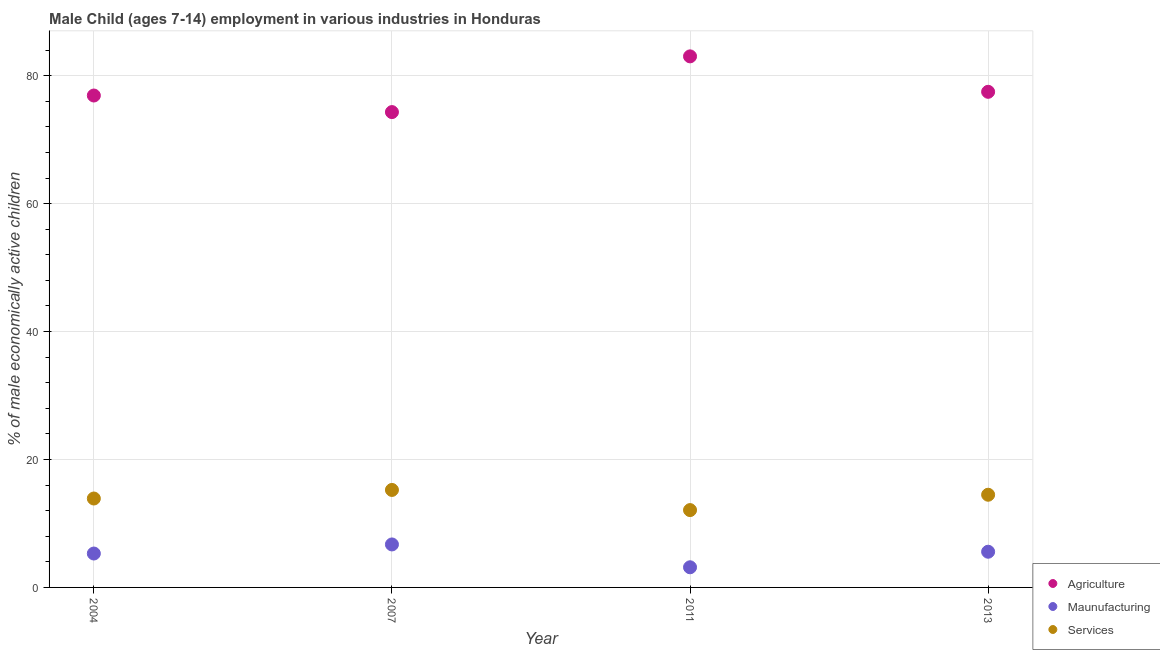What is the percentage of economically active children in agriculture in 2007?
Keep it short and to the point. 74.31. Across all years, what is the maximum percentage of economically active children in services?
Keep it short and to the point. 15.24. Across all years, what is the minimum percentage of economically active children in agriculture?
Offer a terse response. 74.31. In which year was the percentage of economically active children in manufacturing maximum?
Keep it short and to the point. 2007. What is the total percentage of economically active children in agriculture in the graph?
Provide a succinct answer. 311.71. What is the difference between the percentage of economically active children in agriculture in 2004 and that in 2007?
Provide a succinct answer. 2.59. What is the difference between the percentage of economically active children in manufacturing in 2013 and the percentage of economically active children in agriculture in 2004?
Your response must be concise. -71.32. What is the average percentage of economically active children in services per year?
Your answer should be very brief. 13.93. In the year 2004, what is the difference between the percentage of economically active children in manufacturing and percentage of economically active children in agriculture?
Provide a succinct answer. -71.6. What is the ratio of the percentage of economically active children in agriculture in 2007 to that in 2013?
Give a very brief answer. 0.96. Is the percentage of economically active children in services in 2011 less than that in 2013?
Keep it short and to the point. Yes. What is the difference between the highest and the second highest percentage of economically active children in manufacturing?
Ensure brevity in your answer.  1.14. What is the difference between the highest and the lowest percentage of economically active children in agriculture?
Provide a succinct answer. 8.71. Is it the case that in every year, the sum of the percentage of economically active children in agriculture and percentage of economically active children in manufacturing is greater than the percentage of economically active children in services?
Give a very brief answer. Yes. Is the percentage of economically active children in services strictly less than the percentage of economically active children in agriculture over the years?
Your response must be concise. Yes. How many years are there in the graph?
Your response must be concise. 4. Does the graph contain any zero values?
Provide a succinct answer. No. Where does the legend appear in the graph?
Your answer should be very brief. Bottom right. How many legend labels are there?
Provide a short and direct response. 3. What is the title of the graph?
Provide a short and direct response. Male Child (ages 7-14) employment in various industries in Honduras. What is the label or title of the Y-axis?
Give a very brief answer. % of male economically active children. What is the % of male economically active children in Agriculture in 2004?
Give a very brief answer. 76.9. What is the % of male economically active children in Services in 2004?
Provide a short and direct response. 13.9. What is the % of male economically active children in Agriculture in 2007?
Offer a very short reply. 74.31. What is the % of male economically active children in Maunufacturing in 2007?
Provide a short and direct response. 6.72. What is the % of male economically active children in Services in 2007?
Offer a terse response. 15.24. What is the % of male economically active children in Agriculture in 2011?
Make the answer very short. 83.02. What is the % of male economically active children of Maunufacturing in 2011?
Make the answer very short. 3.15. What is the % of male economically active children of Services in 2011?
Make the answer very short. 12.09. What is the % of male economically active children in Agriculture in 2013?
Your response must be concise. 77.48. What is the % of male economically active children in Maunufacturing in 2013?
Make the answer very short. 5.58. What is the % of male economically active children of Services in 2013?
Make the answer very short. 14.49. Across all years, what is the maximum % of male economically active children in Agriculture?
Provide a succinct answer. 83.02. Across all years, what is the maximum % of male economically active children of Maunufacturing?
Provide a succinct answer. 6.72. Across all years, what is the maximum % of male economically active children of Services?
Ensure brevity in your answer.  15.24. Across all years, what is the minimum % of male economically active children of Agriculture?
Your answer should be compact. 74.31. Across all years, what is the minimum % of male economically active children of Maunufacturing?
Your response must be concise. 3.15. Across all years, what is the minimum % of male economically active children in Services?
Ensure brevity in your answer.  12.09. What is the total % of male economically active children of Agriculture in the graph?
Give a very brief answer. 311.71. What is the total % of male economically active children of Maunufacturing in the graph?
Your answer should be compact. 20.75. What is the total % of male economically active children in Services in the graph?
Your response must be concise. 55.72. What is the difference between the % of male economically active children of Agriculture in 2004 and that in 2007?
Your answer should be very brief. 2.59. What is the difference between the % of male economically active children of Maunufacturing in 2004 and that in 2007?
Offer a very short reply. -1.42. What is the difference between the % of male economically active children in Services in 2004 and that in 2007?
Your answer should be very brief. -1.34. What is the difference between the % of male economically active children in Agriculture in 2004 and that in 2011?
Your response must be concise. -6.12. What is the difference between the % of male economically active children of Maunufacturing in 2004 and that in 2011?
Your answer should be very brief. 2.15. What is the difference between the % of male economically active children in Services in 2004 and that in 2011?
Offer a terse response. 1.81. What is the difference between the % of male economically active children in Agriculture in 2004 and that in 2013?
Offer a very short reply. -0.58. What is the difference between the % of male economically active children in Maunufacturing in 2004 and that in 2013?
Ensure brevity in your answer.  -0.28. What is the difference between the % of male economically active children of Services in 2004 and that in 2013?
Offer a terse response. -0.59. What is the difference between the % of male economically active children in Agriculture in 2007 and that in 2011?
Keep it short and to the point. -8.71. What is the difference between the % of male economically active children in Maunufacturing in 2007 and that in 2011?
Your answer should be very brief. 3.57. What is the difference between the % of male economically active children of Services in 2007 and that in 2011?
Your answer should be very brief. 3.15. What is the difference between the % of male economically active children in Agriculture in 2007 and that in 2013?
Provide a short and direct response. -3.17. What is the difference between the % of male economically active children of Maunufacturing in 2007 and that in 2013?
Ensure brevity in your answer.  1.14. What is the difference between the % of male economically active children of Agriculture in 2011 and that in 2013?
Provide a short and direct response. 5.54. What is the difference between the % of male economically active children of Maunufacturing in 2011 and that in 2013?
Offer a very short reply. -2.43. What is the difference between the % of male economically active children of Services in 2011 and that in 2013?
Provide a succinct answer. -2.4. What is the difference between the % of male economically active children in Agriculture in 2004 and the % of male economically active children in Maunufacturing in 2007?
Offer a very short reply. 70.18. What is the difference between the % of male economically active children in Agriculture in 2004 and the % of male economically active children in Services in 2007?
Offer a very short reply. 61.66. What is the difference between the % of male economically active children in Maunufacturing in 2004 and the % of male economically active children in Services in 2007?
Ensure brevity in your answer.  -9.94. What is the difference between the % of male economically active children of Agriculture in 2004 and the % of male economically active children of Maunufacturing in 2011?
Offer a very short reply. 73.75. What is the difference between the % of male economically active children of Agriculture in 2004 and the % of male economically active children of Services in 2011?
Make the answer very short. 64.81. What is the difference between the % of male economically active children in Maunufacturing in 2004 and the % of male economically active children in Services in 2011?
Your response must be concise. -6.79. What is the difference between the % of male economically active children of Agriculture in 2004 and the % of male economically active children of Maunufacturing in 2013?
Your answer should be compact. 71.32. What is the difference between the % of male economically active children in Agriculture in 2004 and the % of male economically active children in Services in 2013?
Provide a succinct answer. 62.41. What is the difference between the % of male economically active children in Maunufacturing in 2004 and the % of male economically active children in Services in 2013?
Offer a terse response. -9.19. What is the difference between the % of male economically active children of Agriculture in 2007 and the % of male economically active children of Maunufacturing in 2011?
Keep it short and to the point. 71.16. What is the difference between the % of male economically active children in Agriculture in 2007 and the % of male economically active children in Services in 2011?
Provide a short and direct response. 62.22. What is the difference between the % of male economically active children in Maunufacturing in 2007 and the % of male economically active children in Services in 2011?
Offer a terse response. -5.37. What is the difference between the % of male economically active children of Agriculture in 2007 and the % of male economically active children of Maunufacturing in 2013?
Make the answer very short. 68.73. What is the difference between the % of male economically active children of Agriculture in 2007 and the % of male economically active children of Services in 2013?
Your answer should be compact. 59.82. What is the difference between the % of male economically active children of Maunufacturing in 2007 and the % of male economically active children of Services in 2013?
Give a very brief answer. -7.77. What is the difference between the % of male economically active children in Agriculture in 2011 and the % of male economically active children in Maunufacturing in 2013?
Your response must be concise. 77.44. What is the difference between the % of male economically active children of Agriculture in 2011 and the % of male economically active children of Services in 2013?
Make the answer very short. 68.53. What is the difference between the % of male economically active children of Maunufacturing in 2011 and the % of male economically active children of Services in 2013?
Keep it short and to the point. -11.34. What is the average % of male economically active children in Agriculture per year?
Your response must be concise. 77.93. What is the average % of male economically active children in Maunufacturing per year?
Ensure brevity in your answer.  5.19. What is the average % of male economically active children of Services per year?
Keep it short and to the point. 13.93. In the year 2004, what is the difference between the % of male economically active children of Agriculture and % of male economically active children of Maunufacturing?
Make the answer very short. 71.6. In the year 2007, what is the difference between the % of male economically active children of Agriculture and % of male economically active children of Maunufacturing?
Your answer should be compact. 67.59. In the year 2007, what is the difference between the % of male economically active children in Agriculture and % of male economically active children in Services?
Make the answer very short. 59.07. In the year 2007, what is the difference between the % of male economically active children of Maunufacturing and % of male economically active children of Services?
Provide a succinct answer. -8.52. In the year 2011, what is the difference between the % of male economically active children of Agriculture and % of male economically active children of Maunufacturing?
Offer a terse response. 79.87. In the year 2011, what is the difference between the % of male economically active children of Agriculture and % of male economically active children of Services?
Your response must be concise. 70.93. In the year 2011, what is the difference between the % of male economically active children in Maunufacturing and % of male economically active children in Services?
Offer a very short reply. -8.94. In the year 2013, what is the difference between the % of male economically active children in Agriculture and % of male economically active children in Maunufacturing?
Provide a short and direct response. 71.9. In the year 2013, what is the difference between the % of male economically active children in Agriculture and % of male economically active children in Services?
Offer a terse response. 62.99. In the year 2013, what is the difference between the % of male economically active children of Maunufacturing and % of male economically active children of Services?
Your answer should be compact. -8.91. What is the ratio of the % of male economically active children of Agriculture in 2004 to that in 2007?
Give a very brief answer. 1.03. What is the ratio of the % of male economically active children of Maunufacturing in 2004 to that in 2007?
Offer a very short reply. 0.79. What is the ratio of the % of male economically active children in Services in 2004 to that in 2007?
Your answer should be compact. 0.91. What is the ratio of the % of male economically active children in Agriculture in 2004 to that in 2011?
Your answer should be compact. 0.93. What is the ratio of the % of male economically active children in Maunufacturing in 2004 to that in 2011?
Your response must be concise. 1.68. What is the ratio of the % of male economically active children of Services in 2004 to that in 2011?
Give a very brief answer. 1.15. What is the ratio of the % of male economically active children in Maunufacturing in 2004 to that in 2013?
Keep it short and to the point. 0.95. What is the ratio of the % of male economically active children of Services in 2004 to that in 2013?
Provide a succinct answer. 0.96. What is the ratio of the % of male economically active children of Agriculture in 2007 to that in 2011?
Provide a short and direct response. 0.9. What is the ratio of the % of male economically active children of Maunufacturing in 2007 to that in 2011?
Offer a terse response. 2.13. What is the ratio of the % of male economically active children in Services in 2007 to that in 2011?
Offer a terse response. 1.26. What is the ratio of the % of male economically active children in Agriculture in 2007 to that in 2013?
Give a very brief answer. 0.96. What is the ratio of the % of male economically active children of Maunufacturing in 2007 to that in 2013?
Keep it short and to the point. 1.2. What is the ratio of the % of male economically active children of Services in 2007 to that in 2013?
Offer a terse response. 1.05. What is the ratio of the % of male economically active children in Agriculture in 2011 to that in 2013?
Your answer should be compact. 1.07. What is the ratio of the % of male economically active children in Maunufacturing in 2011 to that in 2013?
Make the answer very short. 0.56. What is the ratio of the % of male economically active children in Services in 2011 to that in 2013?
Give a very brief answer. 0.83. What is the difference between the highest and the second highest % of male economically active children in Agriculture?
Your answer should be very brief. 5.54. What is the difference between the highest and the second highest % of male economically active children of Maunufacturing?
Keep it short and to the point. 1.14. What is the difference between the highest and the second highest % of male economically active children of Services?
Your answer should be compact. 0.75. What is the difference between the highest and the lowest % of male economically active children in Agriculture?
Offer a terse response. 8.71. What is the difference between the highest and the lowest % of male economically active children of Maunufacturing?
Ensure brevity in your answer.  3.57. What is the difference between the highest and the lowest % of male economically active children in Services?
Your answer should be compact. 3.15. 